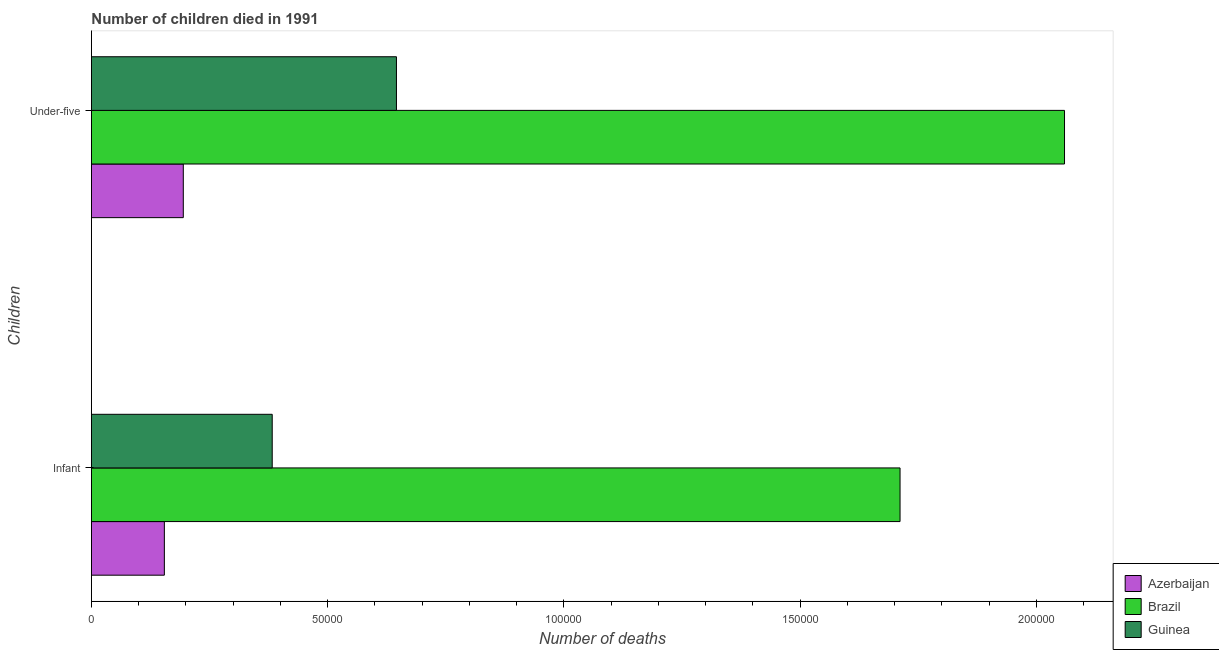How many different coloured bars are there?
Your response must be concise. 3. Are the number of bars per tick equal to the number of legend labels?
Provide a short and direct response. Yes. What is the label of the 2nd group of bars from the top?
Offer a terse response. Infant. What is the number of under-five deaths in Azerbaijan?
Your response must be concise. 1.94e+04. Across all countries, what is the maximum number of under-five deaths?
Ensure brevity in your answer.  2.06e+05. Across all countries, what is the minimum number of infant deaths?
Provide a short and direct response. 1.54e+04. In which country was the number of under-five deaths minimum?
Make the answer very short. Azerbaijan. What is the total number of infant deaths in the graph?
Your answer should be very brief. 2.25e+05. What is the difference between the number of under-five deaths in Brazil and that in Guinea?
Keep it short and to the point. 1.41e+05. What is the difference between the number of infant deaths in Azerbaijan and the number of under-five deaths in Brazil?
Your answer should be very brief. -1.91e+05. What is the average number of infant deaths per country?
Your answer should be very brief. 7.49e+04. What is the difference between the number of infant deaths and number of under-five deaths in Guinea?
Keep it short and to the point. -2.63e+04. In how many countries, is the number of under-five deaths greater than 30000 ?
Your response must be concise. 2. What is the ratio of the number of under-five deaths in Brazil to that in Azerbaijan?
Offer a terse response. 10.59. Is the number of under-five deaths in Guinea less than that in Brazil?
Offer a very short reply. Yes. In how many countries, is the number of under-five deaths greater than the average number of under-five deaths taken over all countries?
Give a very brief answer. 1. What does the 1st bar from the top in Infant represents?
Your answer should be compact. Guinea. What does the 3rd bar from the bottom in Infant represents?
Your response must be concise. Guinea. How many bars are there?
Give a very brief answer. 6. Are all the bars in the graph horizontal?
Ensure brevity in your answer.  Yes. Does the graph contain any zero values?
Your answer should be compact. No. Where does the legend appear in the graph?
Your answer should be compact. Bottom right. How many legend labels are there?
Your response must be concise. 3. How are the legend labels stacked?
Keep it short and to the point. Vertical. What is the title of the graph?
Make the answer very short. Number of children died in 1991. Does "Mozambique" appear as one of the legend labels in the graph?
Offer a very short reply. No. What is the label or title of the X-axis?
Offer a terse response. Number of deaths. What is the label or title of the Y-axis?
Make the answer very short. Children. What is the Number of deaths in Azerbaijan in Infant?
Provide a short and direct response. 1.54e+04. What is the Number of deaths of Brazil in Infant?
Provide a succinct answer. 1.71e+05. What is the Number of deaths of Guinea in Infant?
Ensure brevity in your answer.  3.83e+04. What is the Number of deaths of Azerbaijan in Under-five?
Provide a succinct answer. 1.94e+04. What is the Number of deaths in Brazil in Under-five?
Provide a succinct answer. 2.06e+05. What is the Number of deaths of Guinea in Under-five?
Provide a short and direct response. 6.46e+04. Across all Children, what is the maximum Number of deaths in Azerbaijan?
Keep it short and to the point. 1.94e+04. Across all Children, what is the maximum Number of deaths in Brazil?
Keep it short and to the point. 2.06e+05. Across all Children, what is the maximum Number of deaths of Guinea?
Provide a short and direct response. 6.46e+04. Across all Children, what is the minimum Number of deaths of Azerbaijan?
Your answer should be very brief. 1.54e+04. Across all Children, what is the minimum Number of deaths in Brazil?
Provide a short and direct response. 1.71e+05. Across all Children, what is the minimum Number of deaths in Guinea?
Ensure brevity in your answer.  3.83e+04. What is the total Number of deaths in Azerbaijan in the graph?
Make the answer very short. 3.49e+04. What is the total Number of deaths of Brazil in the graph?
Your answer should be compact. 3.77e+05. What is the total Number of deaths in Guinea in the graph?
Offer a terse response. 1.03e+05. What is the difference between the Number of deaths in Azerbaijan in Infant and that in Under-five?
Ensure brevity in your answer.  -4009. What is the difference between the Number of deaths of Brazil in Infant and that in Under-five?
Ensure brevity in your answer.  -3.48e+04. What is the difference between the Number of deaths in Guinea in Infant and that in Under-five?
Provide a succinct answer. -2.63e+04. What is the difference between the Number of deaths of Azerbaijan in Infant and the Number of deaths of Brazil in Under-five?
Your answer should be compact. -1.91e+05. What is the difference between the Number of deaths in Azerbaijan in Infant and the Number of deaths in Guinea in Under-five?
Make the answer very short. -4.91e+04. What is the difference between the Number of deaths in Brazil in Infant and the Number of deaths in Guinea in Under-five?
Provide a succinct answer. 1.07e+05. What is the average Number of deaths of Azerbaijan per Children?
Offer a terse response. 1.74e+04. What is the average Number of deaths of Brazil per Children?
Make the answer very short. 1.89e+05. What is the average Number of deaths of Guinea per Children?
Ensure brevity in your answer.  5.14e+04. What is the difference between the Number of deaths in Azerbaijan and Number of deaths in Brazil in Infant?
Your response must be concise. -1.56e+05. What is the difference between the Number of deaths of Azerbaijan and Number of deaths of Guinea in Infant?
Provide a succinct answer. -2.28e+04. What is the difference between the Number of deaths in Brazil and Number of deaths in Guinea in Infant?
Your response must be concise. 1.33e+05. What is the difference between the Number of deaths of Azerbaijan and Number of deaths of Brazil in Under-five?
Make the answer very short. -1.87e+05. What is the difference between the Number of deaths of Azerbaijan and Number of deaths of Guinea in Under-five?
Your response must be concise. -4.51e+04. What is the difference between the Number of deaths of Brazil and Number of deaths of Guinea in Under-five?
Your answer should be very brief. 1.41e+05. What is the ratio of the Number of deaths of Azerbaijan in Infant to that in Under-five?
Keep it short and to the point. 0.79. What is the ratio of the Number of deaths in Brazil in Infant to that in Under-five?
Provide a succinct answer. 0.83. What is the ratio of the Number of deaths of Guinea in Infant to that in Under-five?
Your answer should be compact. 0.59. What is the difference between the highest and the second highest Number of deaths of Azerbaijan?
Offer a terse response. 4009. What is the difference between the highest and the second highest Number of deaths of Brazil?
Offer a terse response. 3.48e+04. What is the difference between the highest and the second highest Number of deaths of Guinea?
Offer a terse response. 2.63e+04. What is the difference between the highest and the lowest Number of deaths in Azerbaijan?
Your answer should be very brief. 4009. What is the difference between the highest and the lowest Number of deaths in Brazil?
Offer a terse response. 3.48e+04. What is the difference between the highest and the lowest Number of deaths in Guinea?
Provide a short and direct response. 2.63e+04. 